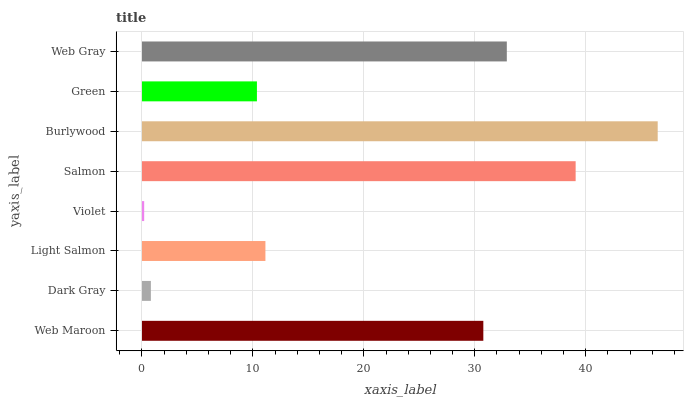Is Violet the minimum?
Answer yes or no. Yes. Is Burlywood the maximum?
Answer yes or no. Yes. Is Dark Gray the minimum?
Answer yes or no. No. Is Dark Gray the maximum?
Answer yes or no. No. Is Web Maroon greater than Dark Gray?
Answer yes or no. Yes. Is Dark Gray less than Web Maroon?
Answer yes or no. Yes. Is Dark Gray greater than Web Maroon?
Answer yes or no. No. Is Web Maroon less than Dark Gray?
Answer yes or no. No. Is Web Maroon the high median?
Answer yes or no. Yes. Is Light Salmon the low median?
Answer yes or no. Yes. Is Web Gray the high median?
Answer yes or no. No. Is Salmon the low median?
Answer yes or no. No. 